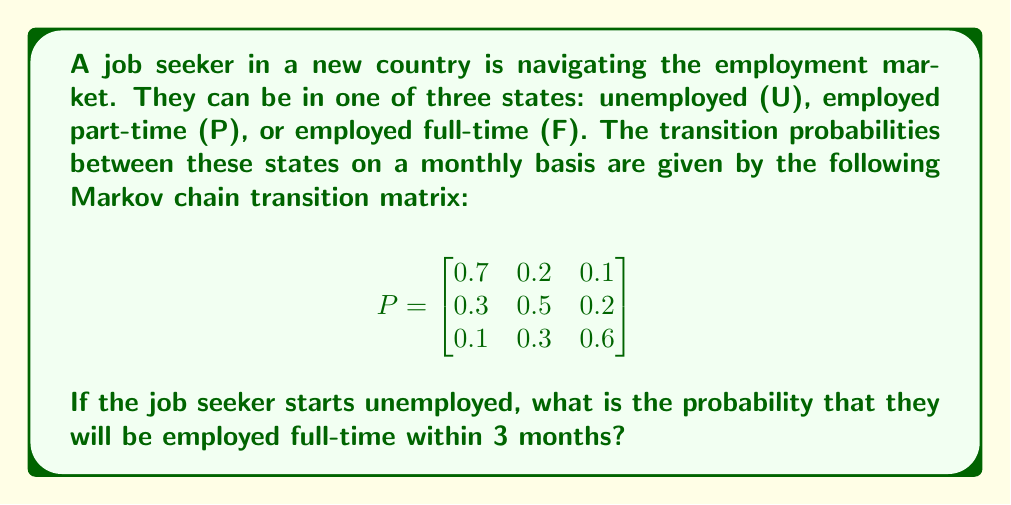Help me with this question. To solve this problem, we need to use the properties of Markov chains and matrix multiplication. Let's approach this step-by-step:

1) First, we need to calculate the probability distribution after 3 months. We can do this by multiplying the initial state vector by the transition matrix three times.

2) The initial state vector is $[1, 0, 0]$ since the job seeker starts unemployed.

3) Let's calculate the state after 1 month:
   $[1, 0, 0] \cdot P = [0.7, 0.2, 0.1]$

4) After 2 months:
   $[0.7, 0.2, 0.1] \cdot P = [0.58, 0.26, 0.16]$

5) After 3 months:
   $[0.58, 0.26, 0.16] \cdot P = [0.517, 0.29, 0.193]$

6) The probability of being in the full-time employed state (F) after 3 months is the last element of this vector: 0.193 or 19.3%.

We can also solve this using matrix exponentiation:

$$P^3 = \begin{bmatrix}
0.517 & 0.29 & 0.193 \\
0.403 & 0.331 & 0.266 \\
0.301 & 0.356 & 0.343
\end{bmatrix}$$

The probability we're looking for is the element in the first row, third column of $P^3$, which is 0.193.
Answer: The probability that the job seeker will be employed full-time within 3 months, starting from unemployment, is 0.193 or 19.3%. 